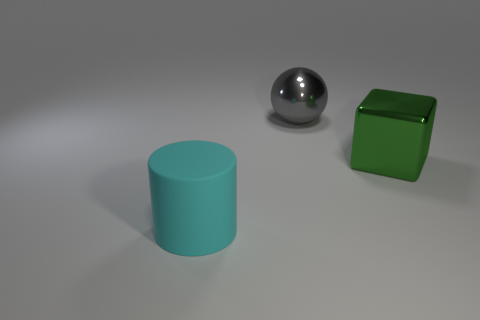Are there any cylinders of the same size as the metallic cube?
Your answer should be compact. Yes. Are there fewer large cubes that are left of the large metallic ball than large gray blocks?
Your answer should be compact. No. What is the size of the green thing that is made of the same material as the large gray thing?
Make the answer very short. Large. Is the number of spheres that are in front of the cyan cylinder less than the number of matte cylinders that are to the left of the large metal sphere?
Give a very brief answer. Yes. There is a big thing right of the gray sphere; is its shape the same as the large cyan rubber object?
Your answer should be very brief. No. Is there any other thing that is the same material as the cylinder?
Provide a short and direct response. No. Are the block that is right of the gray metallic sphere and the large ball made of the same material?
Give a very brief answer. Yes. What is the material of the object that is in front of the big metallic thing that is in front of the large object that is behind the green metallic object?
Offer a terse response. Rubber. How many other things are there of the same shape as the gray object?
Ensure brevity in your answer.  0. There is a big thing that is behind the green object; what is its color?
Make the answer very short. Gray. 